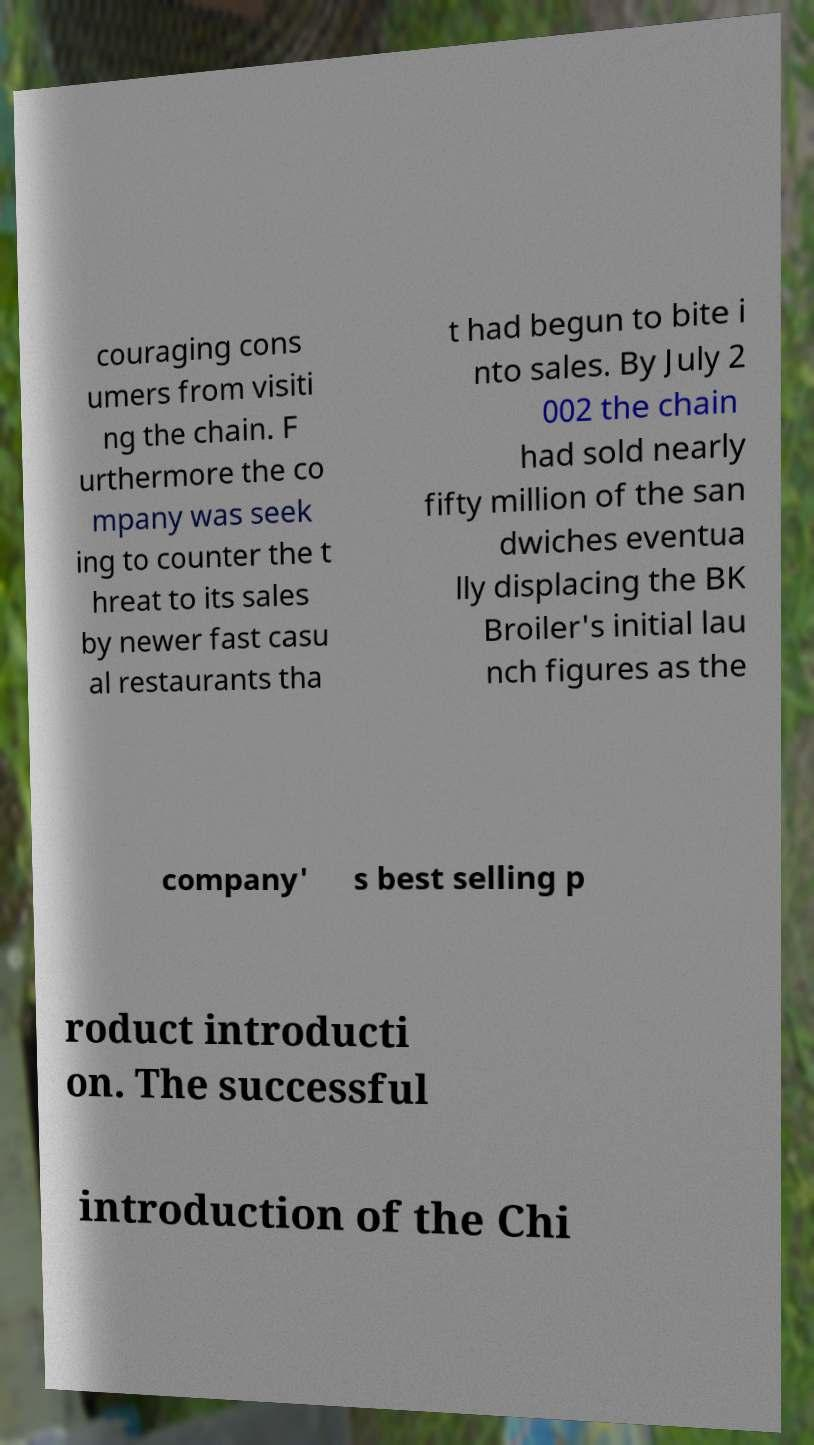There's text embedded in this image that I need extracted. Can you transcribe it verbatim? couraging cons umers from visiti ng the chain. F urthermore the co mpany was seek ing to counter the t hreat to its sales by newer fast casu al restaurants tha t had begun to bite i nto sales. By July 2 002 the chain had sold nearly fifty million of the san dwiches eventua lly displacing the BK Broiler's initial lau nch figures as the company' s best selling p roduct introducti on. The successful introduction of the Chi 